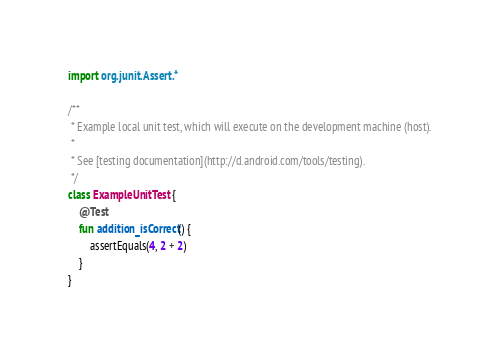Convert code to text. <code><loc_0><loc_0><loc_500><loc_500><_Kotlin_>import org.junit.Assert.*

/**
 * Example local unit test, which will execute on the development machine (host).
 *
 * See [testing documentation](http://d.android.com/tools/testing).
 */
class ExampleUnitTest {
    @Test
    fun addition_isCorrect() {
        assertEquals(4, 2 + 2)
    }
}
</code> 